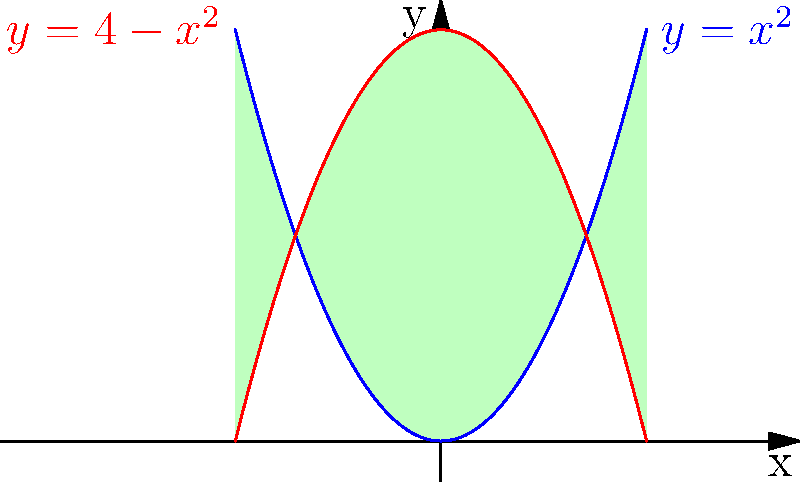As a meticulous press release writer, you're tasked with presenting a geometric challenge to your team. Two parabolas, $y=x^2$ and $y=4-x^2$, intersect to form a bounded region. Calculate the area of this region to demonstrate the importance of precision in both writing and mathematics. Let's approach this step-by-step:

1) First, we need to find the points of intersection. Set the equations equal:
   $$x^2 = 4-x^2$$

2) Solve for x:
   $$2x^2 = 4$$
   $$x^2 = 2$$
   $$x = \pm\sqrt{2}$$

3) The region is symmetric about the y-axis, so we can calculate the area of half the region and double it.

4) The area is the integral of the difference between the two functions from 0 to $\sqrt{2}$:
   $$A = 2\int_0^{\sqrt{2}} [(4-x^2) - x^2] dx$$

5) Simplify the integrand:
   $$A = 2\int_0^{\sqrt{2}} (4-2x^2) dx$$

6) Integrate:
   $$A = 2[4x - \frac{2x^3}{3}]_0^{\sqrt{2}}$$

7) Evaluate the integral:
   $$A = 2[(4\sqrt{2} - \frac{2(\sqrt{2})^3}{3}) - (0 - 0)]$$
   $$A = 2[4\sqrt{2} - \frac{4\sqrt{2}}{3}]$$
   $$A = 2[\frac{12\sqrt{2}}{3} - \frac{4\sqrt{2}}{3}]$$
   $$A = 2[\frac{8\sqrt{2}}{3}]$$
   $$A = \frac{16\sqrt{2}}{3}$$

Therefore, the area of the region is $\frac{16\sqrt{2}}{3}$ square units.
Answer: $\frac{16\sqrt{2}}{3}$ square units 